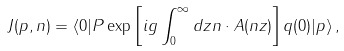<formula> <loc_0><loc_0><loc_500><loc_500>J ( p , n ) = \langle 0 | P \exp \left [ i g \int _ { 0 } ^ { \infty } d z n \cdot A ( n z ) \right ] q ( 0 ) | p \rangle \, ,</formula> 